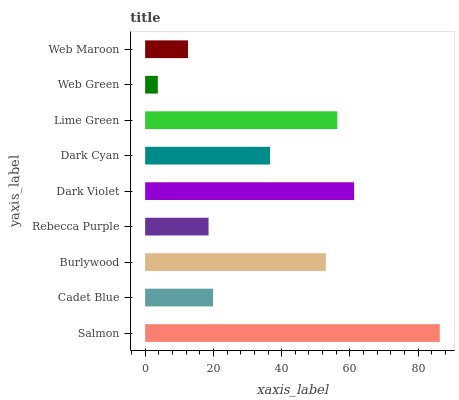Is Web Green the minimum?
Answer yes or no. Yes. Is Salmon the maximum?
Answer yes or no. Yes. Is Cadet Blue the minimum?
Answer yes or no. No. Is Cadet Blue the maximum?
Answer yes or no. No. Is Salmon greater than Cadet Blue?
Answer yes or no. Yes. Is Cadet Blue less than Salmon?
Answer yes or no. Yes. Is Cadet Blue greater than Salmon?
Answer yes or no. No. Is Salmon less than Cadet Blue?
Answer yes or no. No. Is Dark Cyan the high median?
Answer yes or no. Yes. Is Dark Cyan the low median?
Answer yes or no. Yes. Is Burlywood the high median?
Answer yes or no. No. Is Web Maroon the low median?
Answer yes or no. No. 